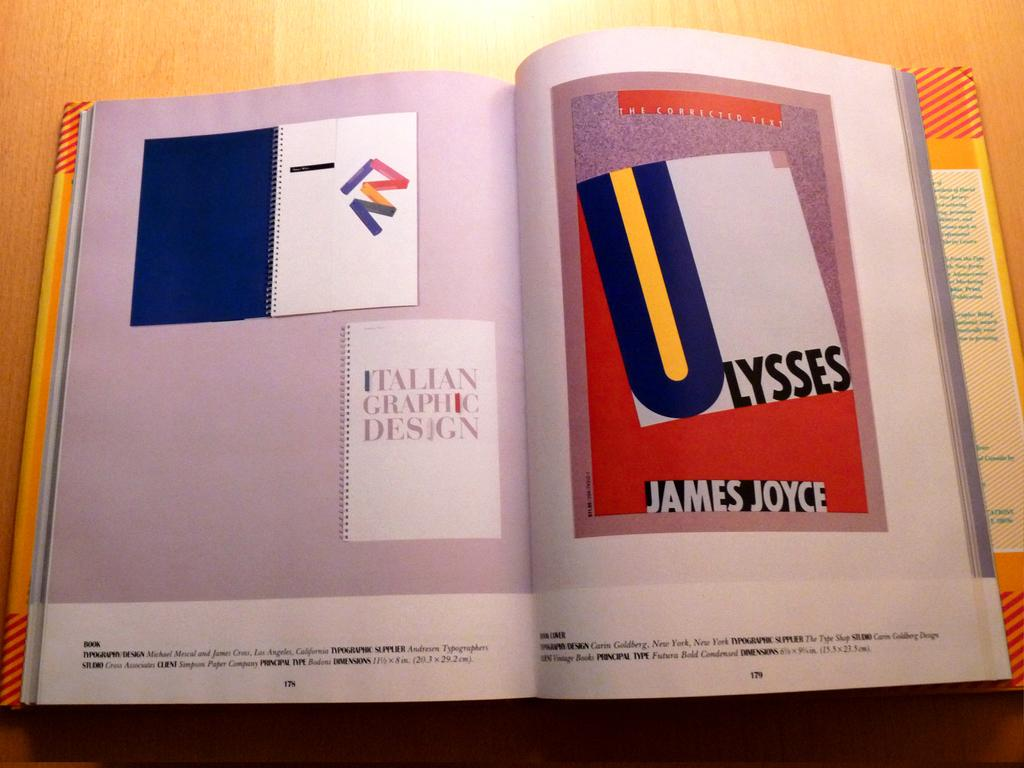<image>
Create a compact narrative representing the image presented. the name James Joyce that is in a magazine 